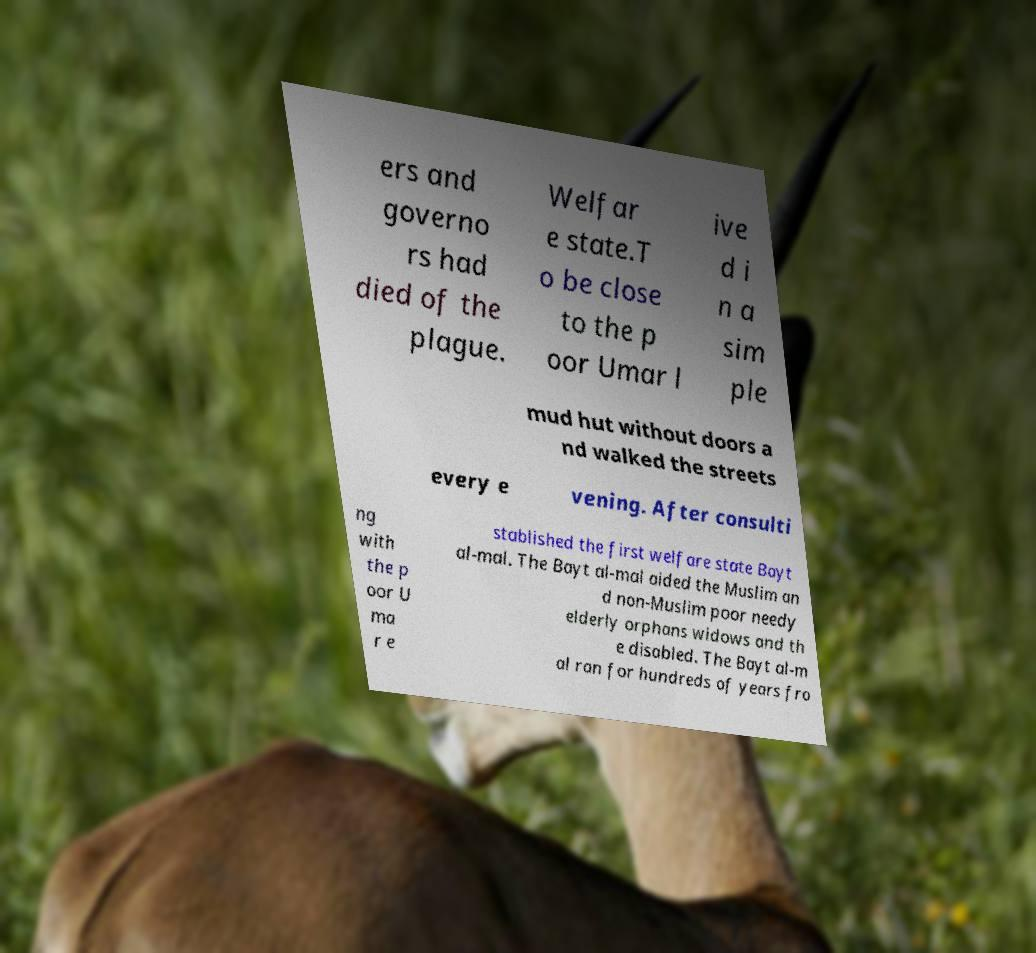Could you extract and type out the text from this image? ers and governo rs had died of the plague. Welfar e state.T o be close to the p oor Umar l ive d i n a sim ple mud hut without doors a nd walked the streets every e vening. After consulti ng with the p oor U ma r e stablished the first welfare state Bayt al-mal. The Bayt al-mal aided the Muslim an d non-Muslim poor needy elderly orphans widows and th e disabled. The Bayt al-m al ran for hundreds of years fro 